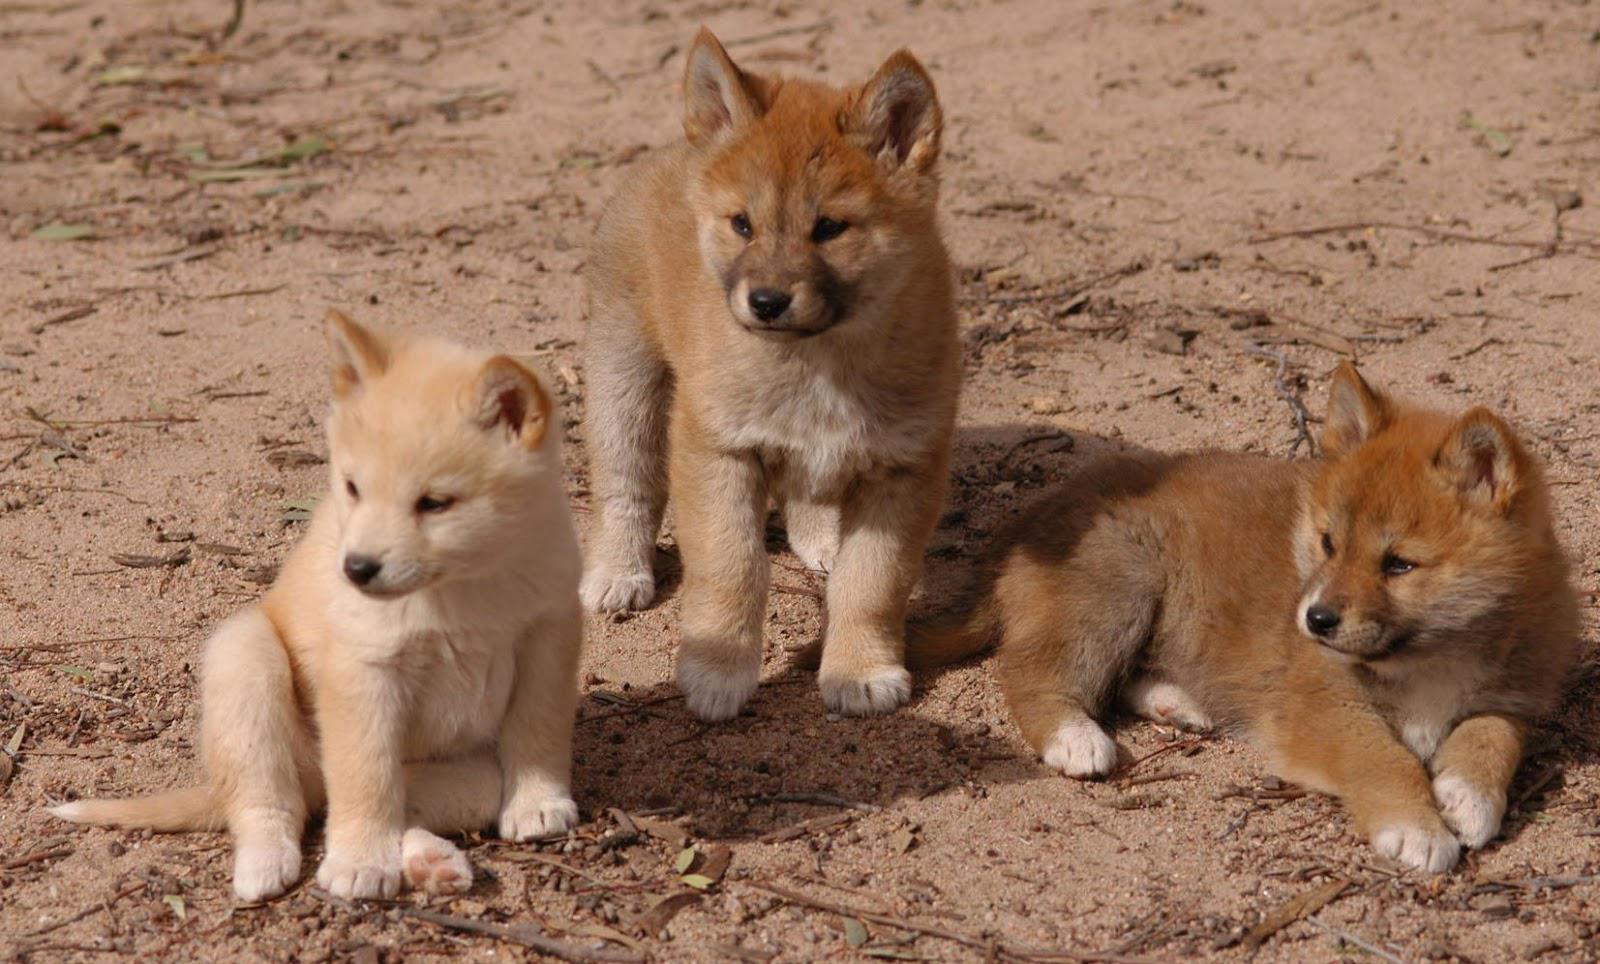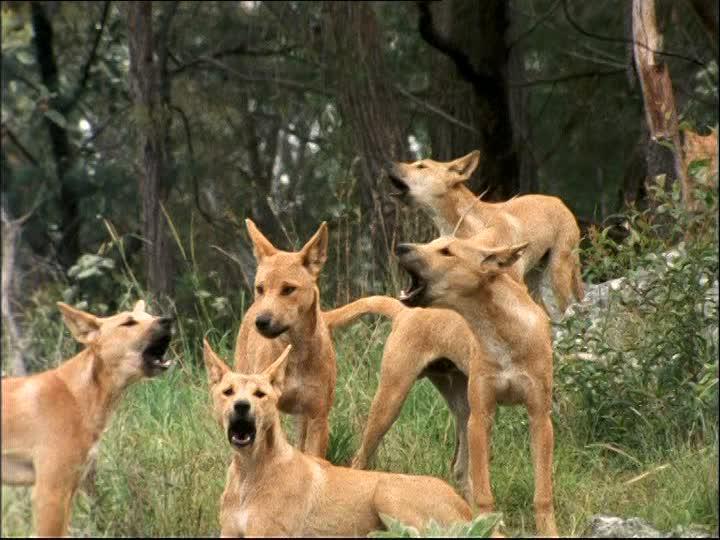The first image is the image on the left, the second image is the image on the right. Examine the images to the left and right. Is the description "An image shows multiple dogs reclining near some type of tree log." accurate? Answer yes or no. No. 